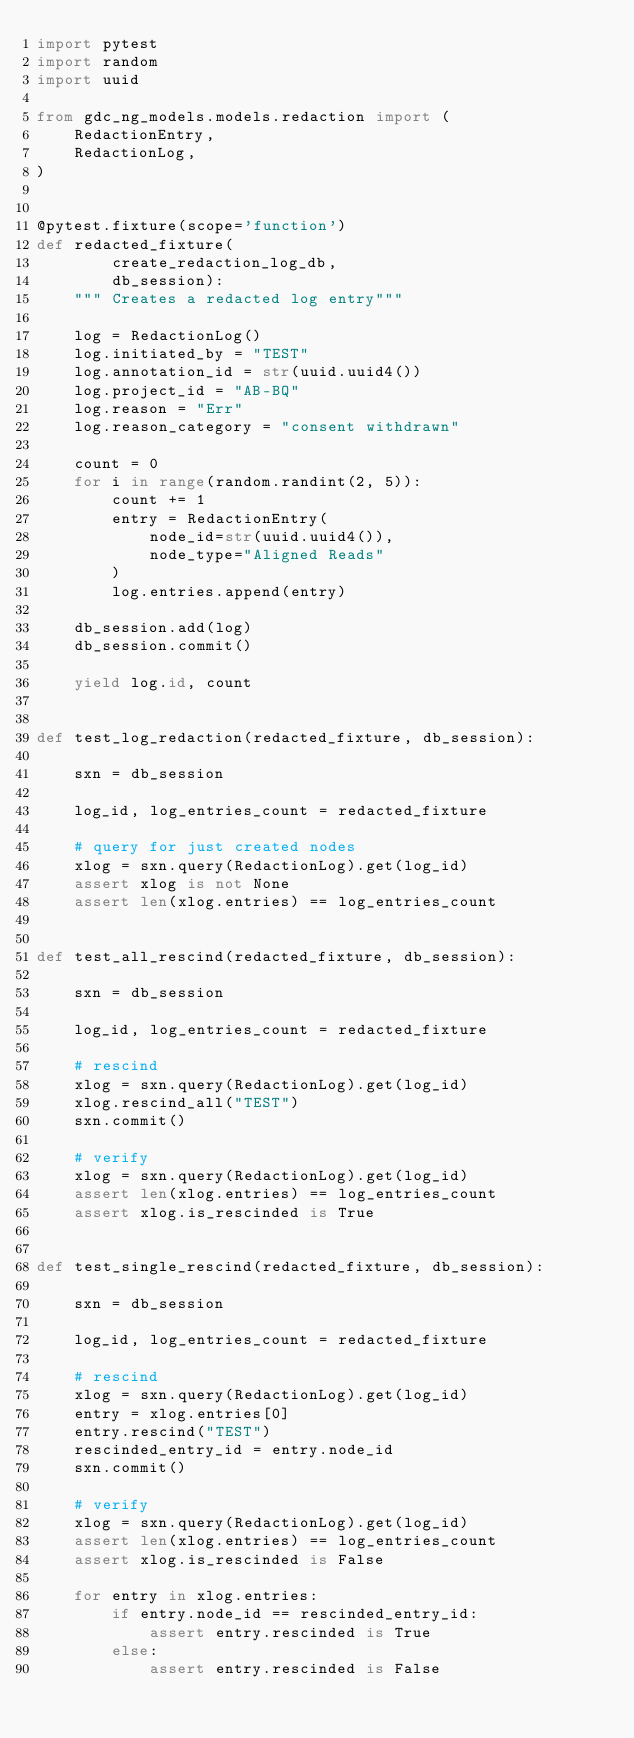<code> <loc_0><loc_0><loc_500><loc_500><_Python_>import pytest
import random
import uuid

from gdc_ng_models.models.redaction import (
    RedactionEntry,
    RedactionLog,
)


@pytest.fixture(scope='function')
def redacted_fixture(
        create_redaction_log_db,
        db_session):
    """ Creates a redacted log entry"""

    log = RedactionLog()
    log.initiated_by = "TEST"
    log.annotation_id = str(uuid.uuid4())
    log.project_id = "AB-BQ"
    log.reason = "Err"
    log.reason_category = "consent withdrawn"

    count = 0
    for i in range(random.randint(2, 5)):
        count += 1
        entry = RedactionEntry(
            node_id=str(uuid.uuid4()),
            node_type="Aligned Reads"
        )
        log.entries.append(entry)

    db_session.add(log)
    db_session.commit()

    yield log.id, count


def test_log_redaction(redacted_fixture, db_session):

    sxn = db_session

    log_id, log_entries_count = redacted_fixture

    # query for just created nodes
    xlog = sxn.query(RedactionLog).get(log_id)
    assert xlog is not None
    assert len(xlog.entries) == log_entries_count


def test_all_rescind(redacted_fixture, db_session):

    sxn = db_session

    log_id, log_entries_count = redacted_fixture

    # rescind
    xlog = sxn.query(RedactionLog).get(log_id)
    xlog.rescind_all("TEST")
    sxn.commit()

    # verify
    xlog = sxn.query(RedactionLog).get(log_id)
    assert len(xlog.entries) == log_entries_count
    assert xlog.is_rescinded is True


def test_single_rescind(redacted_fixture, db_session):

    sxn = db_session

    log_id, log_entries_count = redacted_fixture

    # rescind
    xlog = sxn.query(RedactionLog).get(log_id)
    entry = xlog.entries[0]
    entry.rescind("TEST")
    rescinded_entry_id = entry.node_id
    sxn.commit()

    # verify
    xlog = sxn.query(RedactionLog).get(log_id)
    assert len(xlog.entries) == log_entries_count
    assert xlog.is_rescinded is False

    for entry in xlog.entries:
        if entry.node_id == rescinded_entry_id:
            assert entry.rescinded is True
        else:
            assert entry.rescinded is False
</code> 